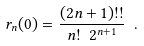<formula> <loc_0><loc_0><loc_500><loc_500>r _ { n } ( 0 ) = \frac { ( 2 n + 1 ) ! ! } { n ! \ 2 ^ { n + 1 } } \ .</formula> 